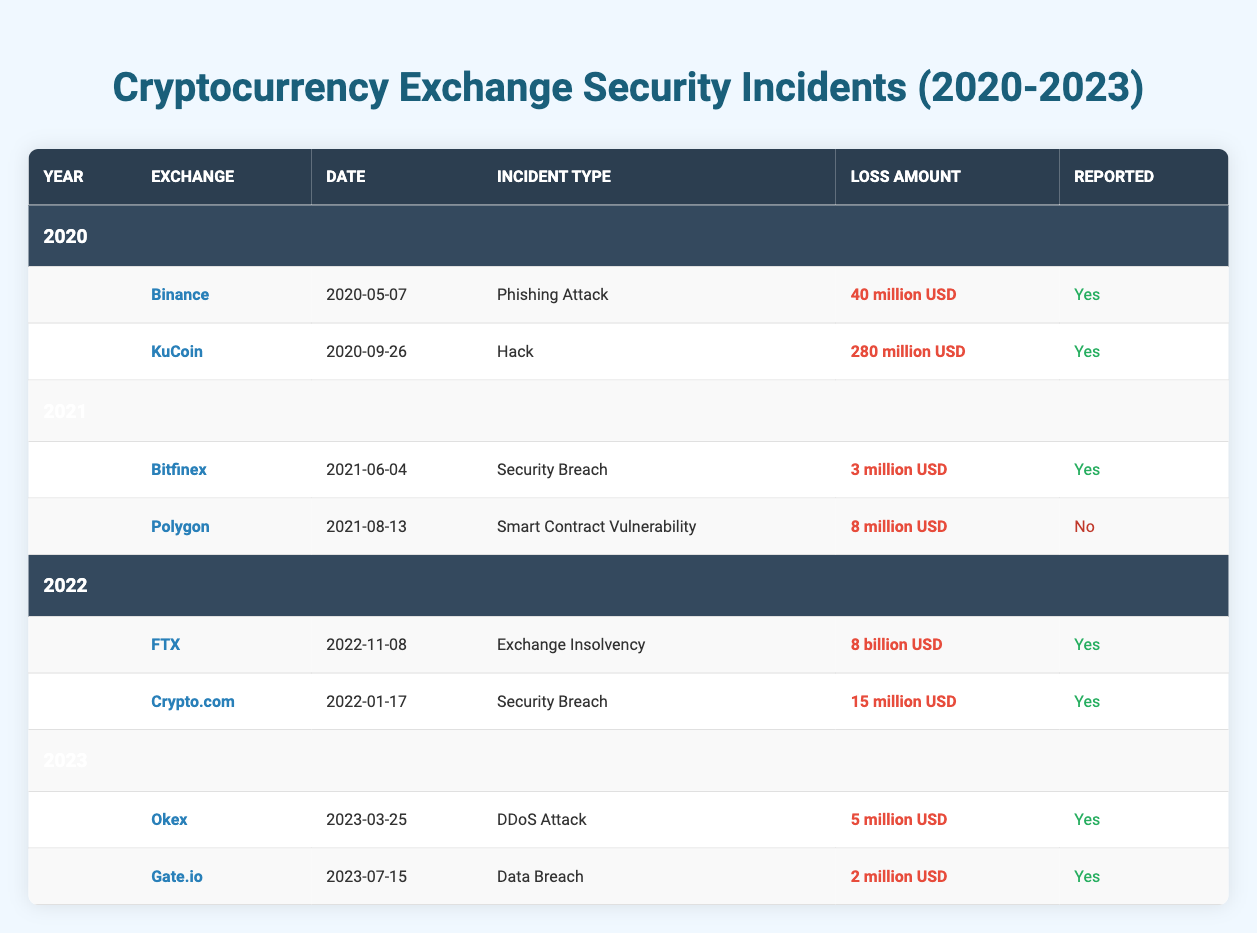What type of incident did KuCoin report in 2020? According to the table, within the entry for KuCoin under the year 2020, the incident type listed is "Hack."
Answer: Hack How much loss did Binance incur from its incident in 2020? The table shows that Binance reported a loss amount of "40 million USD" in its incident entry for the year 2020.
Answer: 40 million USD Did Polygon report its security incident in 2021? The table indicates that Polygon had an incident labeled as "Smart Contract Vulnerability" in 2021, but it explicitly lists "No" under the "Reported" column.
Answer: No What was the combined loss amount from the incidents reported in 2022? According to the table, Crypto.com reported a loss of "15 million USD" and FTX reported a loss of "8 billion USD." To find the combined loss, we convert "8 billion USD" to "8,000 million USD" and add both: 8,000 million + 15 million = 8,015 million USD.
Answer: 8,015 million USD Which exchange incurred the highest financial loss from incidents in the table? By reviewing each loss amount from the table, FTX reported the highest loss of "8 billion USD." This value is significantly higher than all other exchanges' losses listed in the table, such as KuCoin's "280 million USD" and others.
Answer: FTX 